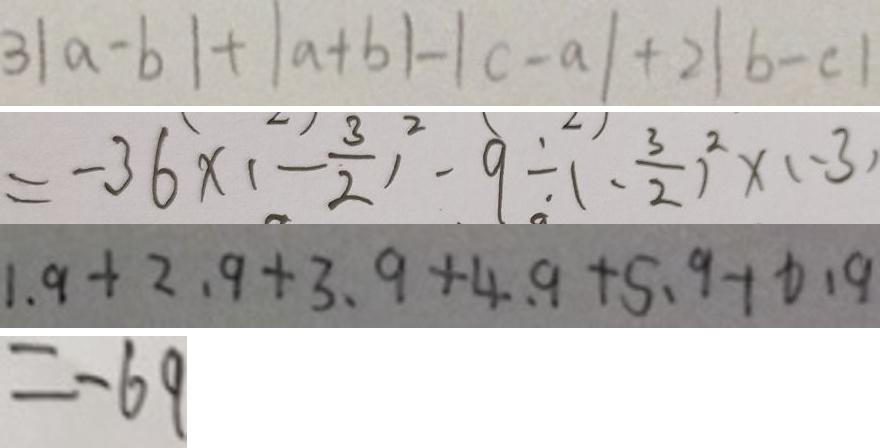<formula> <loc_0><loc_0><loc_500><loc_500>3 \vert a - b \vert + \vert a + b \vert - \vert c - a \vert + 2 \vert b - c \vert 
 = - 3 6 \times ( - \frac { 3 } { 2 } ) ^ { 2 } - 9 \div ( - \frac { 3 } { 2 } ) ^ { 2 } \times ( - 3 ) 
 1 . 9 + 2 . 9 + 3 . 9 + 4 . 9 + 5 . 9 + 6 . 9 
 = - 6 9</formula> 